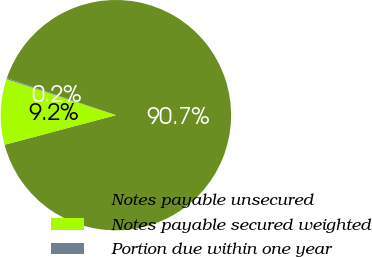Convert chart. <chart><loc_0><loc_0><loc_500><loc_500><pie_chart><fcel>Notes payable unsecured<fcel>Notes payable secured weighted<fcel>Portion due within one year<nl><fcel>90.65%<fcel>9.2%<fcel>0.15%<nl></chart> 